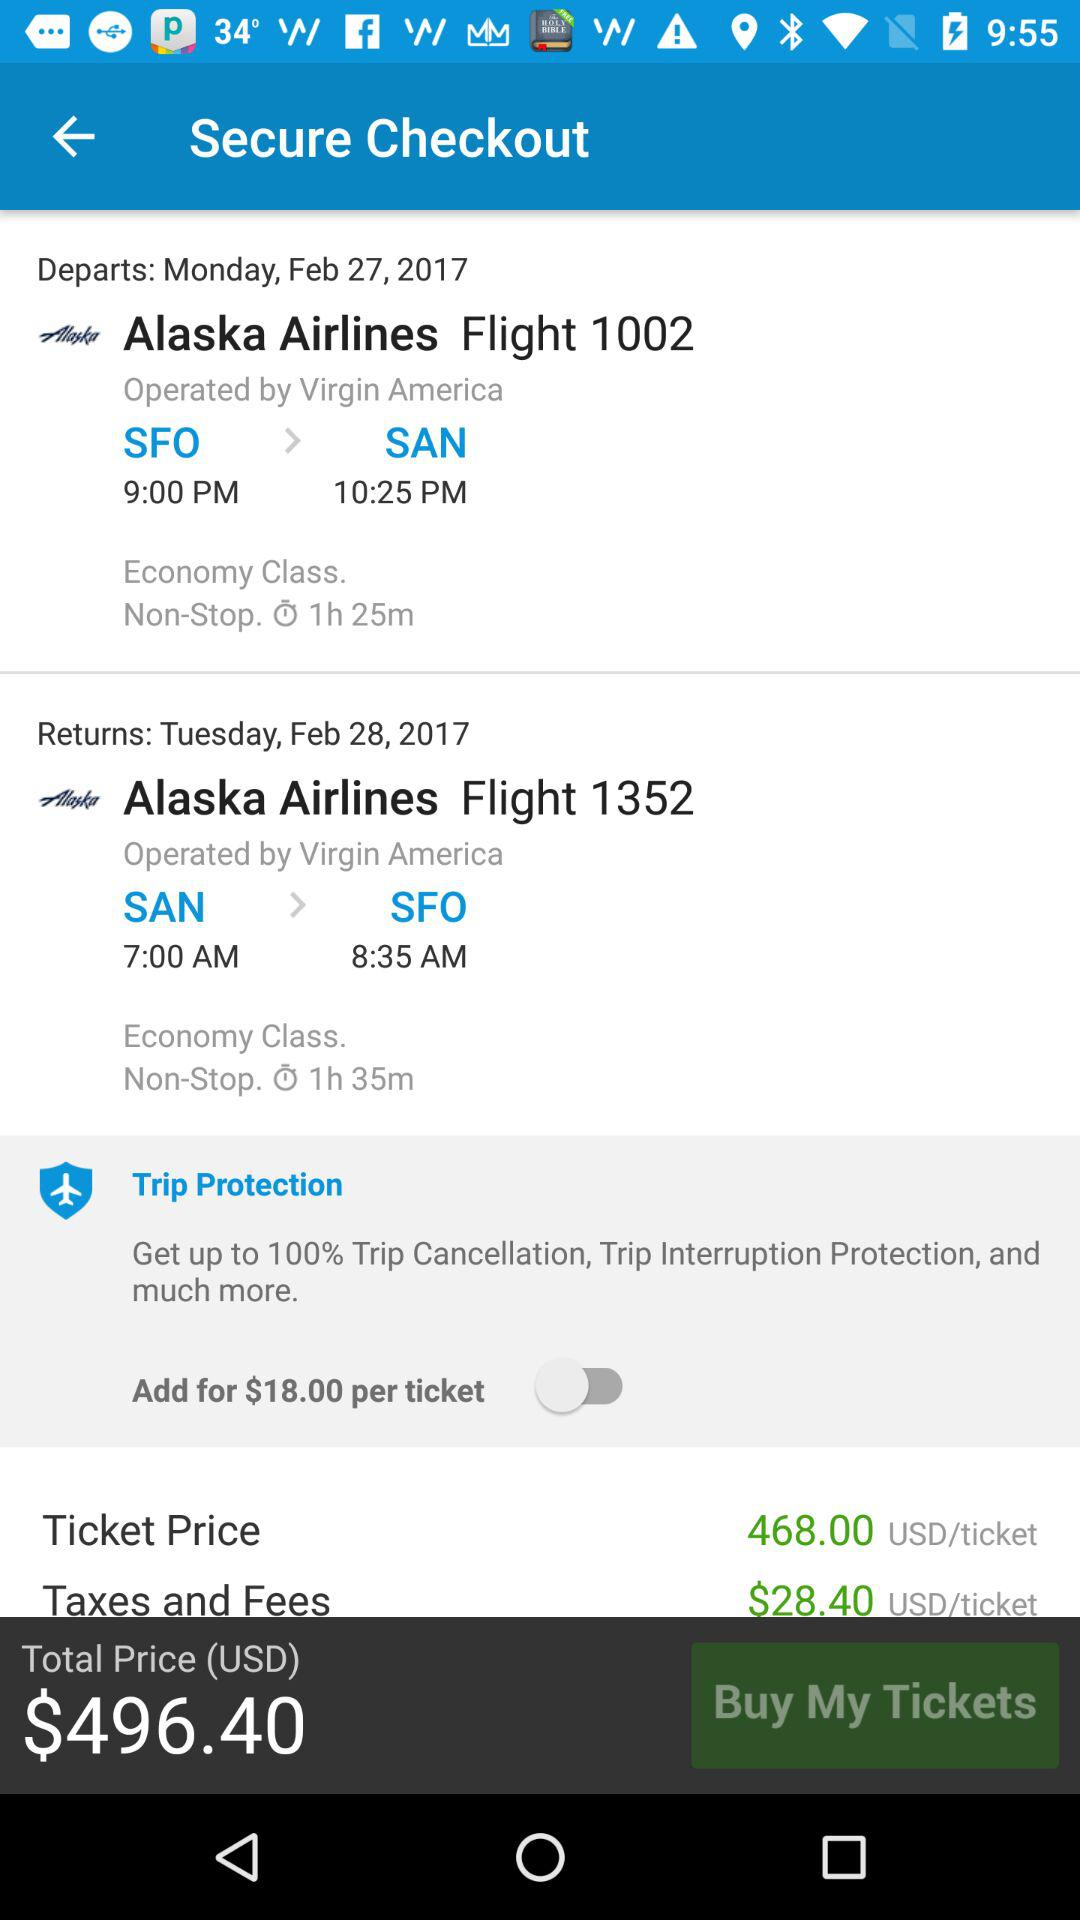What are the ticket prices? The price is 468.00 USD/ticket. 